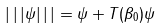<formula> <loc_0><loc_0><loc_500><loc_500>| \, | \, | \psi | \, | \, | = \| \psi \| + \| T ( \beta _ { 0 } ) \psi \|</formula> 